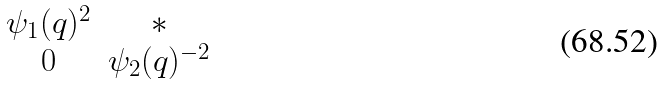Convert formula to latex. <formula><loc_0><loc_0><loc_500><loc_500>\begin{matrix} \psi _ { 1 } ( q ) ^ { 2 } & * \\ 0 & \psi _ { 2 } ( q ) ^ { - 2 } \end{matrix}</formula> 